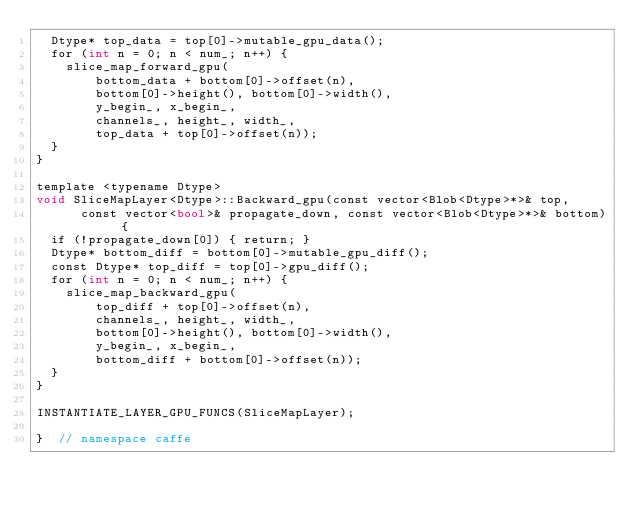Convert code to text. <code><loc_0><loc_0><loc_500><loc_500><_Cuda_>  Dtype* top_data = top[0]->mutable_gpu_data();
  for (int n = 0; n < num_; n++) {
    slice_map_forward_gpu(
        bottom_data + bottom[0]->offset(n),
        bottom[0]->height(), bottom[0]->width(),
        y_begin_, x_begin_,
        channels_, height_, width_,
        top_data + top[0]->offset(n));
  }
}

template <typename Dtype>
void SliceMapLayer<Dtype>::Backward_gpu(const vector<Blob<Dtype>*>& top,
      const vector<bool>& propagate_down, const vector<Blob<Dtype>*>& bottom) {
  if (!propagate_down[0]) { return; }
  Dtype* bottom_diff = bottom[0]->mutable_gpu_diff();
  const Dtype* top_diff = top[0]->gpu_diff();
  for (int n = 0; n < num_; n++) {
    slice_map_backward_gpu(
        top_diff + top[0]->offset(n),
        channels_, height_, width_,
        bottom[0]->height(), bottom[0]->width(),
        y_begin_, x_begin_,
        bottom_diff + bottom[0]->offset(n));
  }
}

INSTANTIATE_LAYER_GPU_FUNCS(SliceMapLayer);

}  // namespace caffe
</code> 